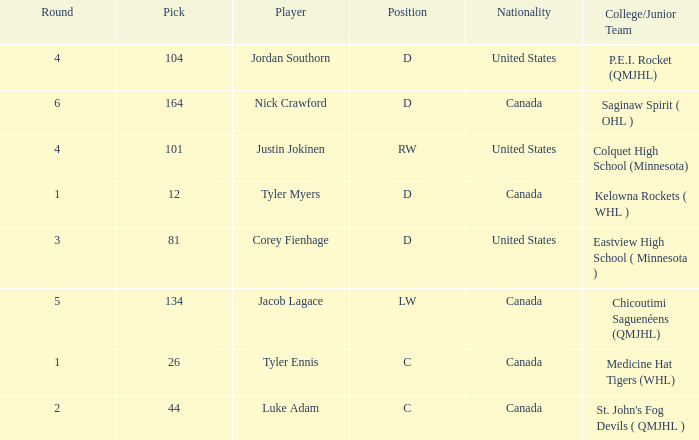What is the nationality of player corey fienhage, who has a pick less than 104? United States. 